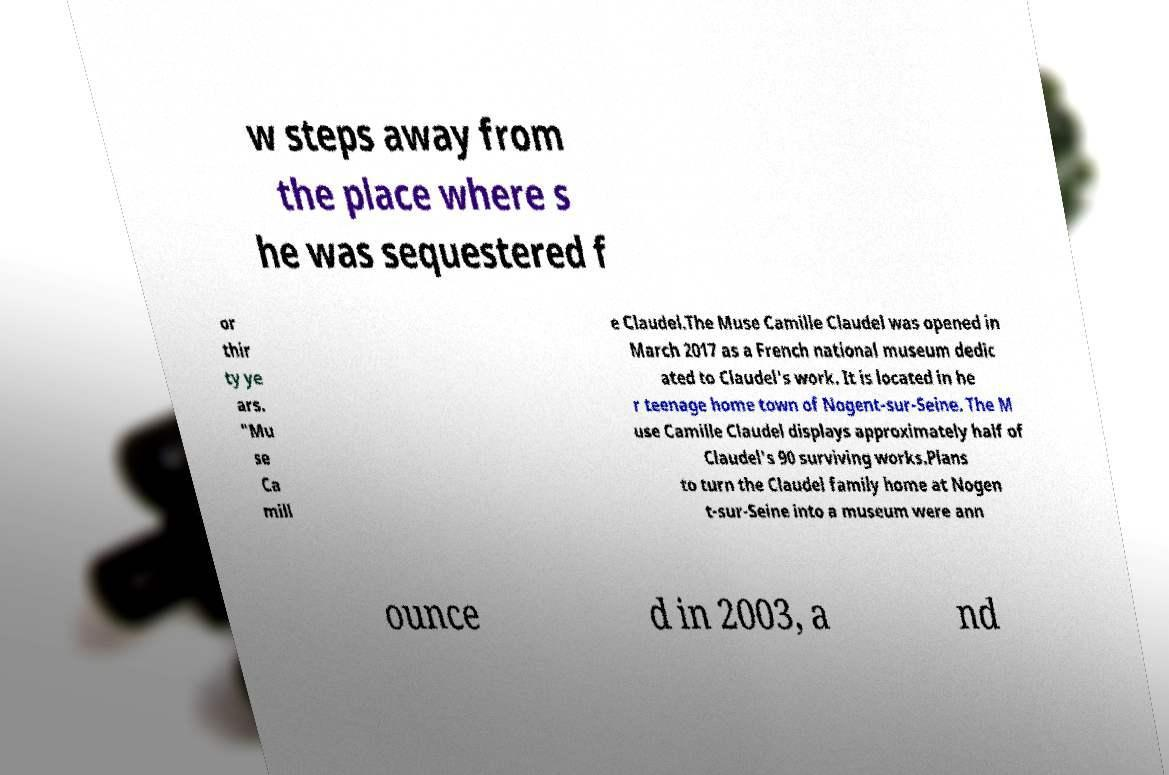What messages or text are displayed in this image? I need them in a readable, typed format. w steps away from the place where s he was sequestered f or thir ty ye ars. "Mu se Ca mill e Claudel.The Muse Camille Claudel was opened in March 2017 as a French national museum dedic ated to Claudel's work. It is located in he r teenage home town of Nogent-sur-Seine. The M use Camille Claudel displays approximately half of Claudel's 90 surviving works.Plans to turn the Claudel family home at Nogen t-sur-Seine into a museum were ann ounce d in 2003, a nd 